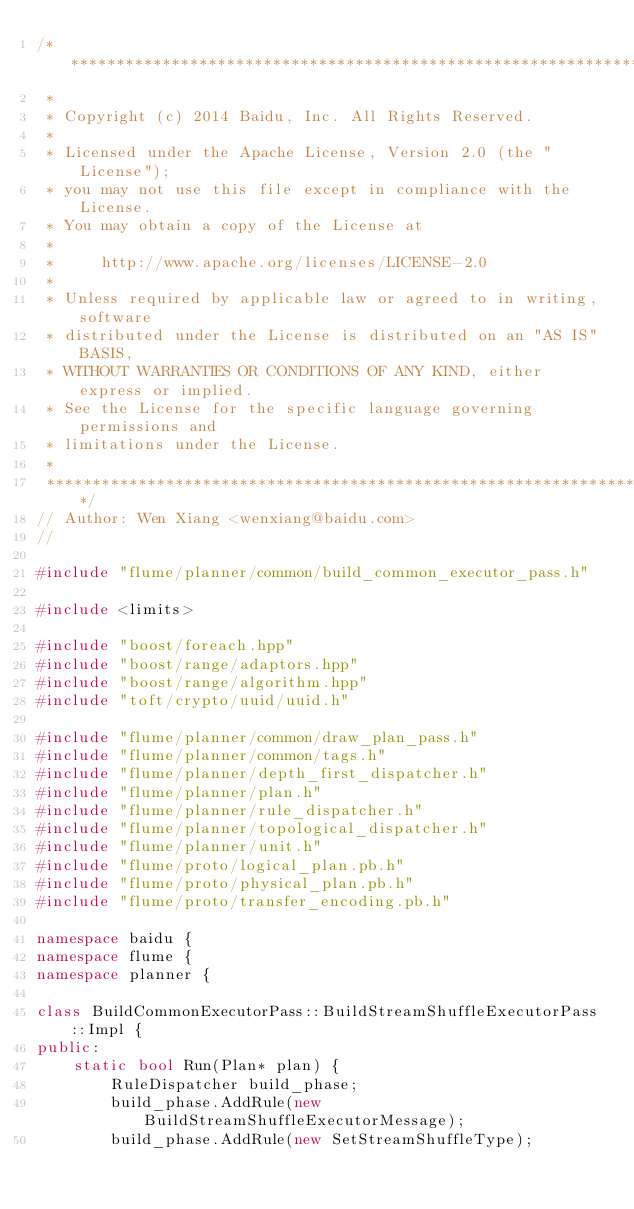Convert code to text. <code><loc_0><loc_0><loc_500><loc_500><_C++_>/***************************************************************************
 *
 * Copyright (c) 2014 Baidu, Inc. All Rights Reserved.
 *
 * Licensed under the Apache License, Version 2.0 (the "License");
 * you may not use this file except in compliance with the License.
 * You may obtain a copy of the License at
 *
 *     http://www.apache.org/licenses/LICENSE-2.0
 *
 * Unless required by applicable law or agreed to in writing, software
 * distributed under the License is distributed on an "AS IS" BASIS,
 * WITHOUT WARRANTIES OR CONDITIONS OF ANY KIND, either express or implied.
 * See the License for the specific language governing permissions and
 * limitations under the License.
 *
 **************************************************************************/
// Author: Wen Xiang <wenxiang@baidu.com>
//

#include "flume/planner/common/build_common_executor_pass.h"

#include <limits>

#include "boost/foreach.hpp"
#include "boost/range/adaptors.hpp"
#include "boost/range/algorithm.hpp"
#include "toft/crypto/uuid/uuid.h"

#include "flume/planner/common/draw_plan_pass.h"
#include "flume/planner/common/tags.h"
#include "flume/planner/depth_first_dispatcher.h"
#include "flume/planner/plan.h"
#include "flume/planner/rule_dispatcher.h"
#include "flume/planner/topological_dispatcher.h"
#include "flume/planner/unit.h"
#include "flume/proto/logical_plan.pb.h"
#include "flume/proto/physical_plan.pb.h"
#include "flume/proto/transfer_encoding.pb.h"

namespace baidu {
namespace flume {
namespace planner {

class BuildCommonExecutorPass::BuildStreamShuffleExecutorPass::Impl {
public:
    static bool Run(Plan* plan) {
        RuleDispatcher build_phase;
        build_phase.AddRule(new BuildStreamShuffleExecutorMessage);
        build_phase.AddRule(new SetStreamShuffleType);</code> 